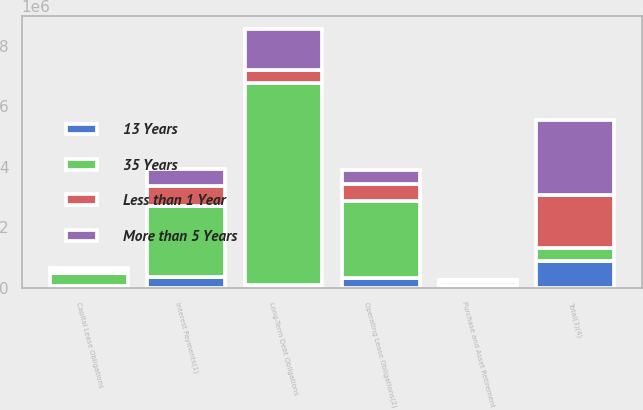<chart> <loc_0><loc_0><loc_500><loc_500><stacked_bar_chart><ecel><fcel>Capital Lease Obligations<fcel>Long-Term Debt Obligations<fcel>Interest Payments(1)<fcel>Operating Lease Obligations(2)<fcel>Purchase and Asset Retirement<fcel>Total(3)(4)<nl><fcel>35 Years<fcel>436285<fcel>6.69477e+06<fcel>2.37177e+06<fcel>2.56689e+06<fcel>145706<fcel>436285<nl><fcel>13 Years<fcel>57902<fcel>88398<fcel>344207<fcel>313922<fcel>78368<fcel>882797<nl><fcel>Less than 1 Year<fcel>89276<fcel>418365<fcel>644351<fcel>563408<fcel>30512<fcel>1.74591e+06<nl><fcel>More than 5 Years<fcel>61217<fcel>1.36363e+06<fcel>578874<fcel>467533<fcel>7881<fcel>2.47914e+06<nl></chart> 